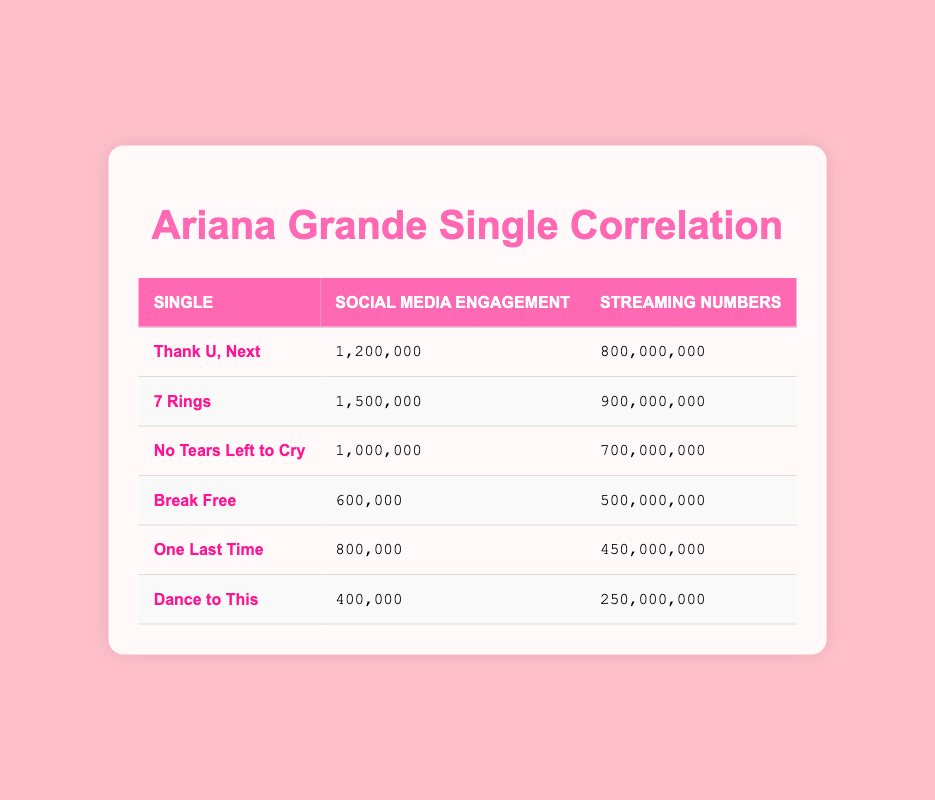What is the streaming number for "7 Rings"? The streaming number is specifically listed in the row for "7 Rings." It shows 900,000,000.
Answer: 900,000,000 Which single has the highest social media engagement? By inspecting the social media engagement numbers, "7 Rings" has the highest value at 1,500,000.
Answer: 7 Rings What is the total social media engagement for all singles listed? To find the total, add up the social media engagement values: 1200000 + 1500000 + 1000000 + 600000 + 800000 + 400000 = 5,600,000.
Answer: 5,600,000 Is the streaming number for "Dance to This" greater than that for "Break Free"? The streaming number for "Dance to This" is 250,000,000 and for "Break Free" it's 500,000,000, making it false that "Dance to This" has a higher number.
Answer: No What is the average social media engagement of the singles? Calculate the average by adding all social media engagement numbers: 1200000 + 1500000 + 1000000 + 600000 + 800000 + 400000 = 5,600,000, then divide by 6 (the total number of singles): 5,600,000 / 6 = 933,333.33.
Answer: 933,333.33 What can be said about the correlation between social media engagement and streaming numbers for "No Tears Left to Cry" compared to "Break Free"? For "No Tears Left to Cry", social media engagement is 1,000,000 with streaming at 700,000,000; for "Break Free", it's 600,000 engagement with 500,000,000 streaming. Higher engagement correlates with higher streaming.
Answer: Engagement correlates with streaming 